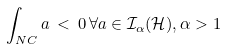Convert formula to latex. <formula><loc_0><loc_0><loc_500><loc_500>\int _ { N C } a \, < \, 0 \, \forall a \in { \mathcal { I } } _ { \alpha } ( { \mathcal { H } } ) , \alpha > 1</formula> 